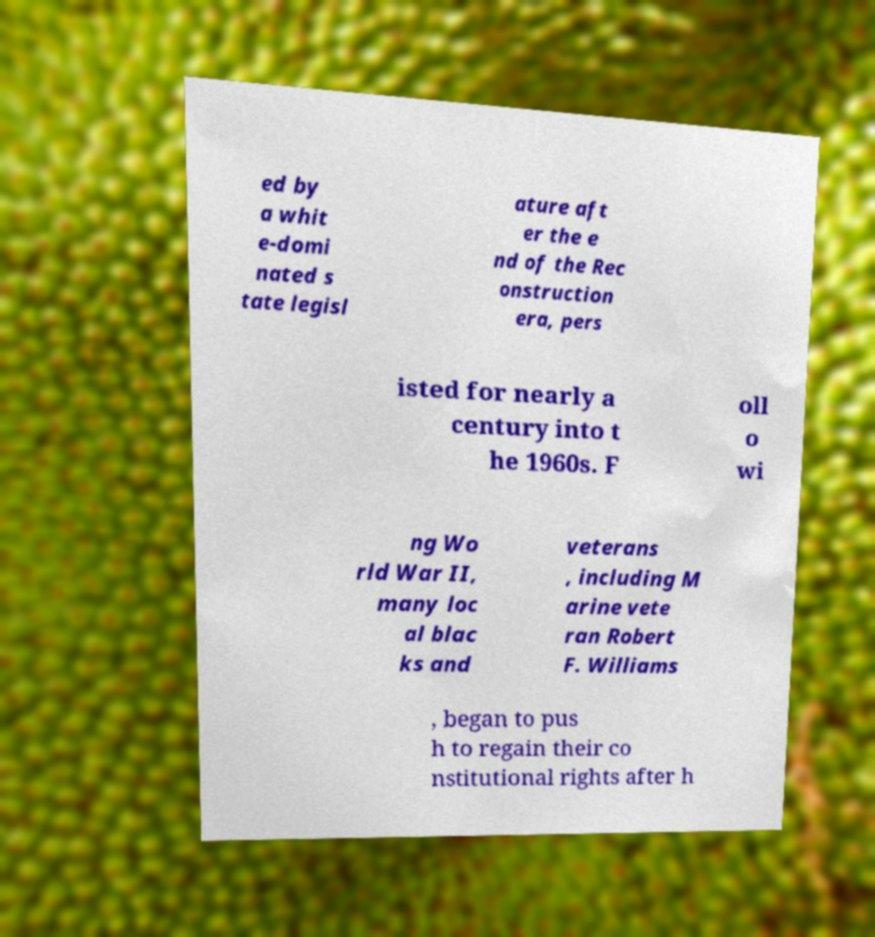Could you extract and type out the text from this image? ed by a whit e-domi nated s tate legisl ature aft er the e nd of the Rec onstruction era, pers isted for nearly a century into t he 1960s. F oll o wi ng Wo rld War II, many loc al blac ks and veterans , including M arine vete ran Robert F. Williams , began to pus h to regain their co nstitutional rights after h 